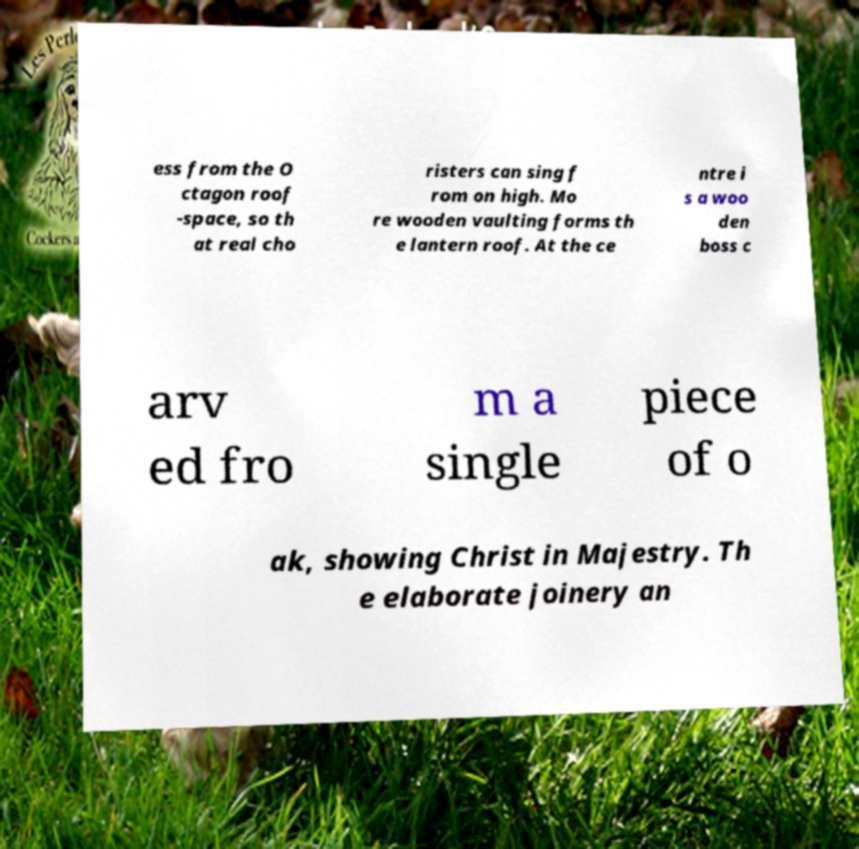Can you read and provide the text displayed in the image?This photo seems to have some interesting text. Can you extract and type it out for me? ess from the O ctagon roof -space, so th at real cho risters can sing f rom on high. Mo re wooden vaulting forms th e lantern roof. At the ce ntre i s a woo den boss c arv ed fro m a single piece of o ak, showing Christ in Majestry. Th e elaborate joinery an 